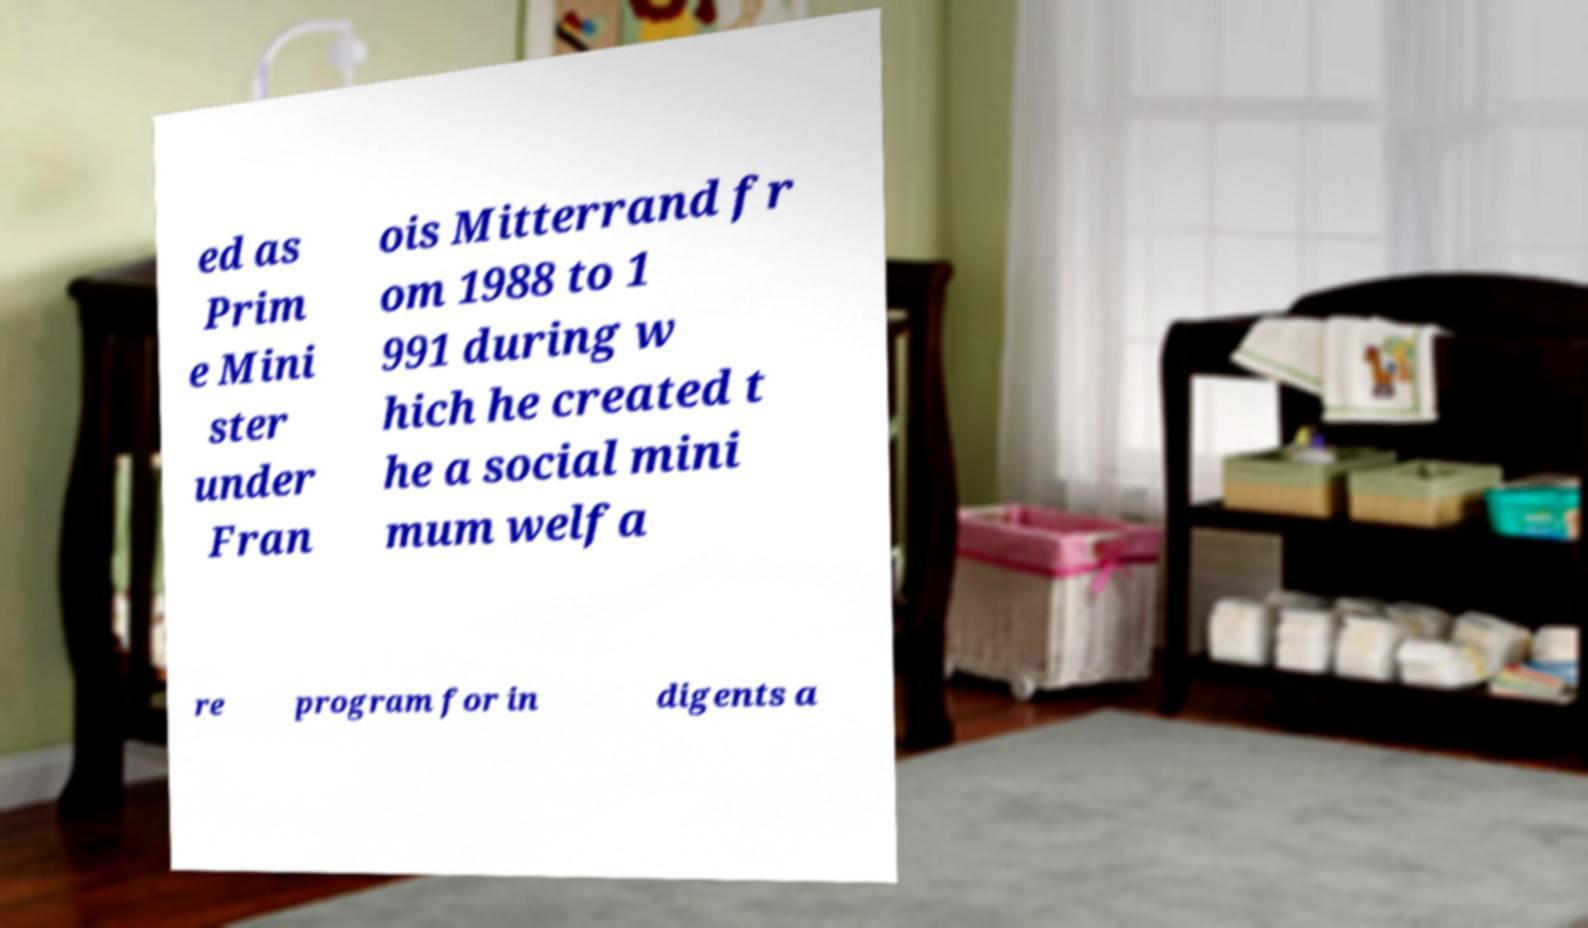Could you extract and type out the text from this image? ed as Prim e Mini ster under Fran ois Mitterrand fr om 1988 to 1 991 during w hich he created t he a social mini mum welfa re program for in digents a 